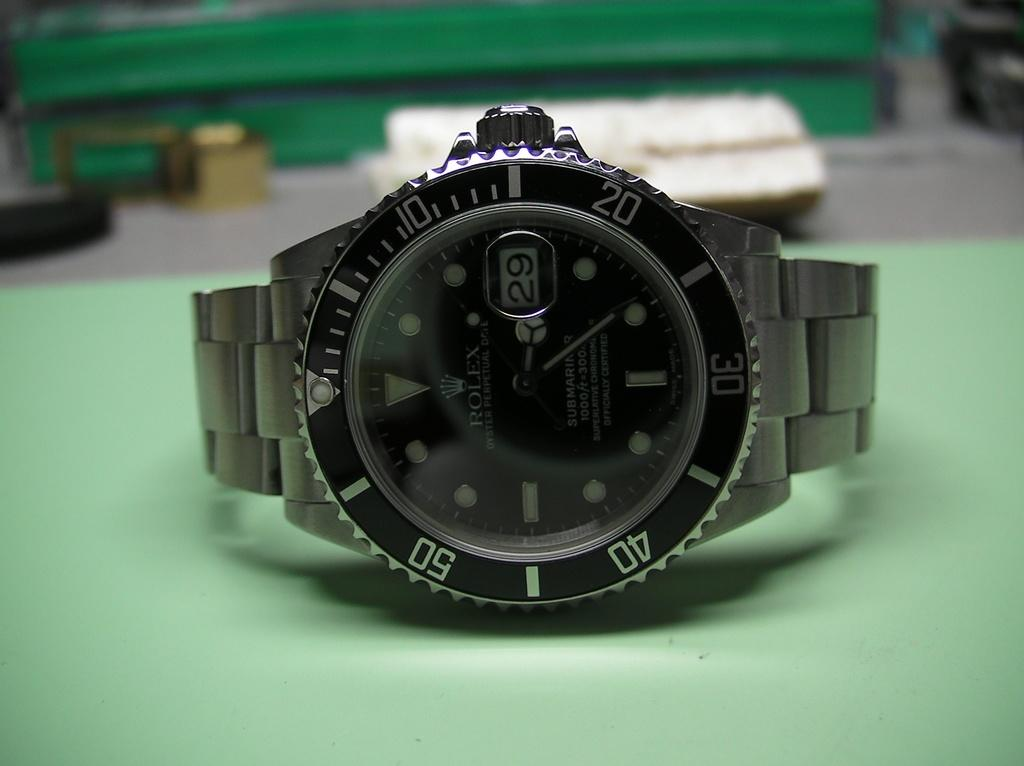Provide a one-sentence caption for the provided image. A Rolex watch laying on its side on a green surface. 